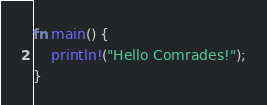<code> <loc_0><loc_0><loc_500><loc_500><_Rust_>
fn main() {
	println!("Hello Comrades!");
}
</code> 